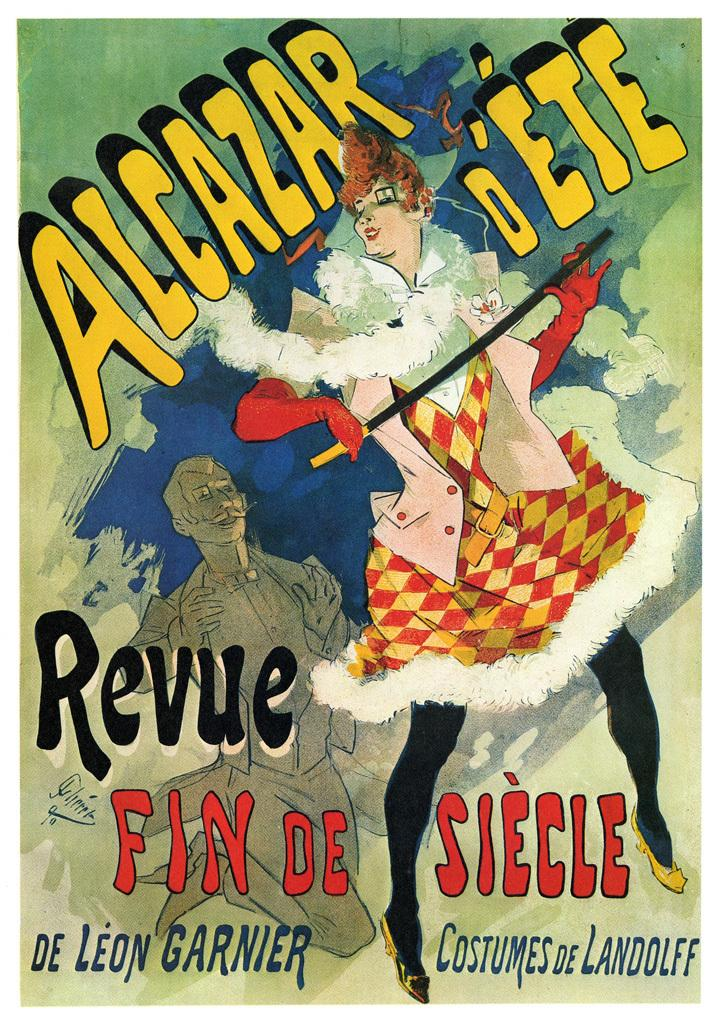<image>
Present a compact description of the photo's key features. The cover of a magazine, movie, or ad with the words Alcazar D'ete 